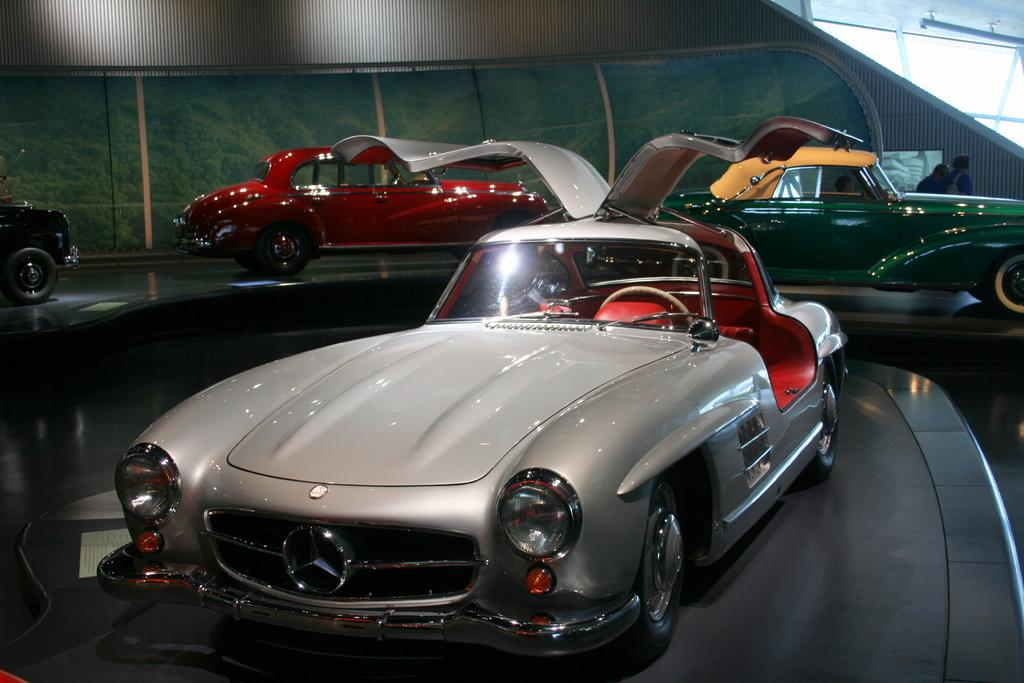What type of vehicles are in the picture? There are antique cars of different colors in the picture. How many people are in the picture? There are two persons in the picture. What can be seen on the top right side of the image? There are glass windows on the top right side of the image. What type of corn is being distributed by the persons in the image? There is no corn or distribution activity present in the image. What is the name of the antique car on the left side of the image? The provided facts do not include the names of the antique cars, so it cannot be determined from the image. 